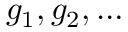<formula> <loc_0><loc_0><loc_500><loc_500>g _ { 1 } , g _ { 2 } , \dots</formula> 